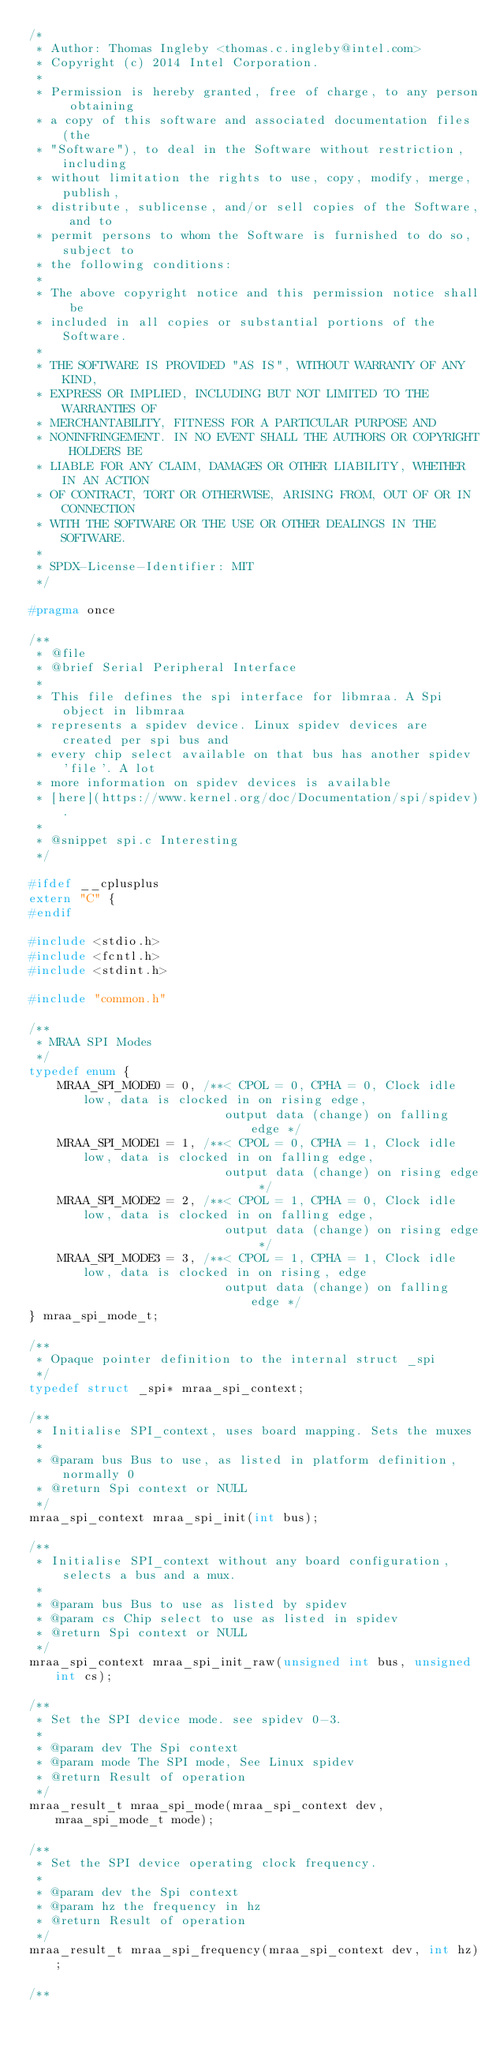Convert code to text. <code><loc_0><loc_0><loc_500><loc_500><_C_>/*
 * Author: Thomas Ingleby <thomas.c.ingleby@intel.com>
 * Copyright (c) 2014 Intel Corporation.
 *
 * Permission is hereby granted, free of charge, to any person obtaining
 * a copy of this software and associated documentation files (the
 * "Software"), to deal in the Software without restriction, including
 * without limitation the rights to use, copy, modify, merge, publish,
 * distribute, sublicense, and/or sell copies of the Software, and to
 * permit persons to whom the Software is furnished to do so, subject to
 * the following conditions:
 *
 * The above copyright notice and this permission notice shall be
 * included in all copies or substantial portions of the Software.
 *
 * THE SOFTWARE IS PROVIDED "AS IS", WITHOUT WARRANTY OF ANY KIND,
 * EXPRESS OR IMPLIED, INCLUDING BUT NOT LIMITED TO THE WARRANTIES OF
 * MERCHANTABILITY, FITNESS FOR A PARTICULAR PURPOSE AND
 * NONINFRINGEMENT. IN NO EVENT SHALL THE AUTHORS OR COPYRIGHT HOLDERS BE
 * LIABLE FOR ANY CLAIM, DAMAGES OR OTHER LIABILITY, WHETHER IN AN ACTION
 * OF CONTRACT, TORT OR OTHERWISE, ARISING FROM, OUT OF OR IN CONNECTION
 * WITH THE SOFTWARE OR THE USE OR OTHER DEALINGS IN THE SOFTWARE.
 *
 * SPDX-License-Identifier: MIT
 */

#pragma once

/**
 * @file
 * @brief Serial Peripheral Interface
 *
 * This file defines the spi interface for libmraa. A Spi object in libmraa
 * represents a spidev device. Linux spidev devices are created per spi bus and
 * every chip select available on that bus has another spidev 'file'. A lot
 * more information on spidev devices is available
 * [here](https://www.kernel.org/doc/Documentation/spi/spidev).
 *
 * @snippet spi.c Interesting
 */

#ifdef __cplusplus
extern "C" {
#endif

#include <stdio.h>
#include <fcntl.h>
#include <stdint.h>

#include "common.h"

/**
 * MRAA SPI Modes
 */
typedef enum {
    MRAA_SPI_MODE0 = 0, /**< CPOL = 0, CPHA = 0, Clock idle low, data is clocked in on rising edge,
                           output data (change) on falling edge */
    MRAA_SPI_MODE1 = 1, /**< CPOL = 0, CPHA = 1, Clock idle low, data is clocked in on falling edge,
                           output data (change) on rising edge */
    MRAA_SPI_MODE2 = 2, /**< CPOL = 1, CPHA = 0, Clock idle low, data is clocked in on falling edge,
                           output data (change) on rising edge */
    MRAA_SPI_MODE3 = 3, /**< CPOL = 1, CPHA = 1, Clock idle low, data is clocked in on rising, edge
                           output data (change) on falling edge */
} mraa_spi_mode_t;

/**
 * Opaque pointer definition to the internal struct _spi
 */
typedef struct _spi* mraa_spi_context;

/**
 * Initialise SPI_context, uses board mapping. Sets the muxes
 *
 * @param bus Bus to use, as listed in platform definition, normally 0
 * @return Spi context or NULL
 */
mraa_spi_context mraa_spi_init(int bus);

/**
 * Initialise SPI_context without any board configuration, selects a bus and a mux.
 *
 * @param bus Bus to use as listed by spidev
 * @param cs Chip select to use as listed in spidev
 * @return Spi context or NULL
 */
mraa_spi_context mraa_spi_init_raw(unsigned int bus, unsigned int cs);

/**
 * Set the SPI device mode. see spidev 0-3.
 *
 * @param dev The Spi context
 * @param mode The SPI mode, See Linux spidev
 * @return Result of operation
 */
mraa_result_t mraa_spi_mode(mraa_spi_context dev, mraa_spi_mode_t mode);

/**
 * Set the SPI device operating clock frequency.
 *
 * @param dev the Spi context
 * @param hz the frequency in hz
 * @return Result of operation
 */
mraa_result_t mraa_spi_frequency(mraa_spi_context dev, int hz);

/**</code> 